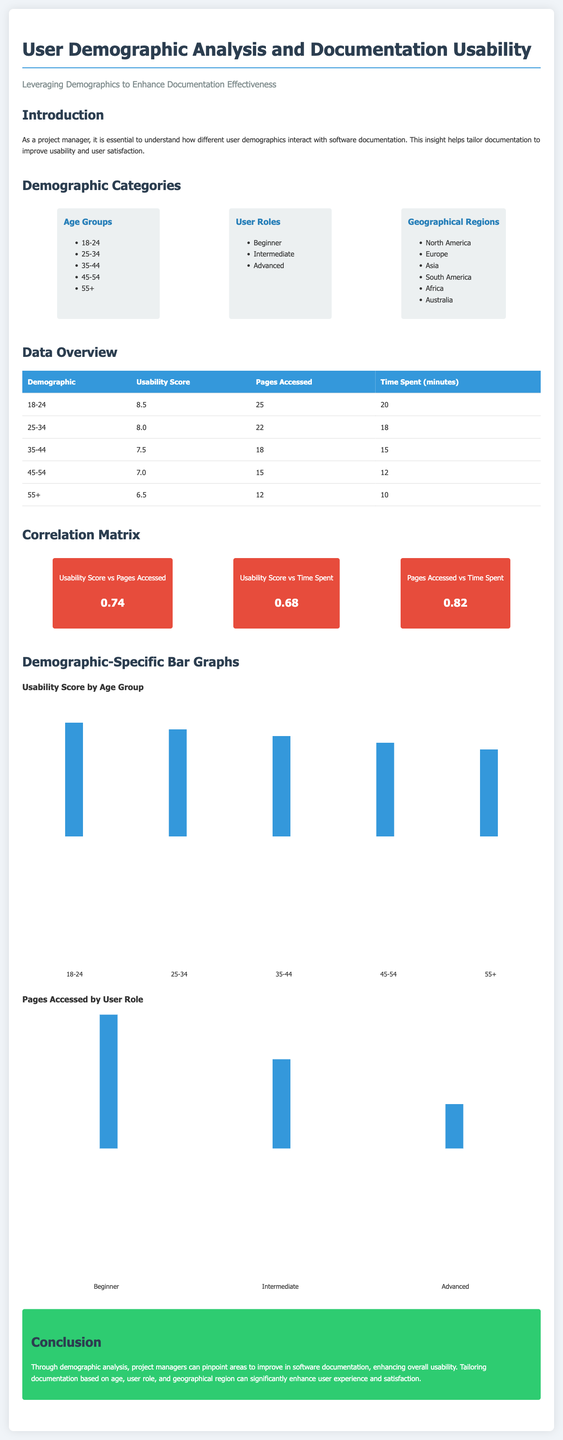what is the Usability Score for the age group 18-24? The Usability Score is stated in the table under the column "Usability Score" for the age group 18-24.
Answer: 8.5 how many pages did the users aged 45-54 access? The number of pages accessed is indicated in the table under the column "Pages Accessed" for the age group 45-54.
Answer: 15 what is the correlation value between Usability Score and Time Spent? The correlation value is provided in the correlation matrix section.
Answer: 0.68 which user role accessed the most pages? The user role with the highest bar in the "Pages Accessed by User Role" graph indicates which role accessed the most pages.
Answer: Beginner what is the highest Usability Score in the data overview? The highest Usability Score can be found in the table by comparing all values in the "Usability Score" column.
Answer: 8.5 how many minutes did users aged 55 and above typically spend? The time spent is given in the "Time Spent (minutes)" column for the age group 55+.
Answer: 10 what does the conclusion highlight about tailoring documentation? The conclusion includes a summary of the insights gained through demographic analysis regarding usability improvements.
Answer: Enhance user experience and satisfaction what is the average Usability Score for the age group 35-44? The average can be found directly in the "Usability Score" column for that age group.
Answer: 7.5 which geographical region is mentioned in the demographic categories? The document lists various geographical regions in the demographics section, where one can find the relevant information.
Answer: North America 